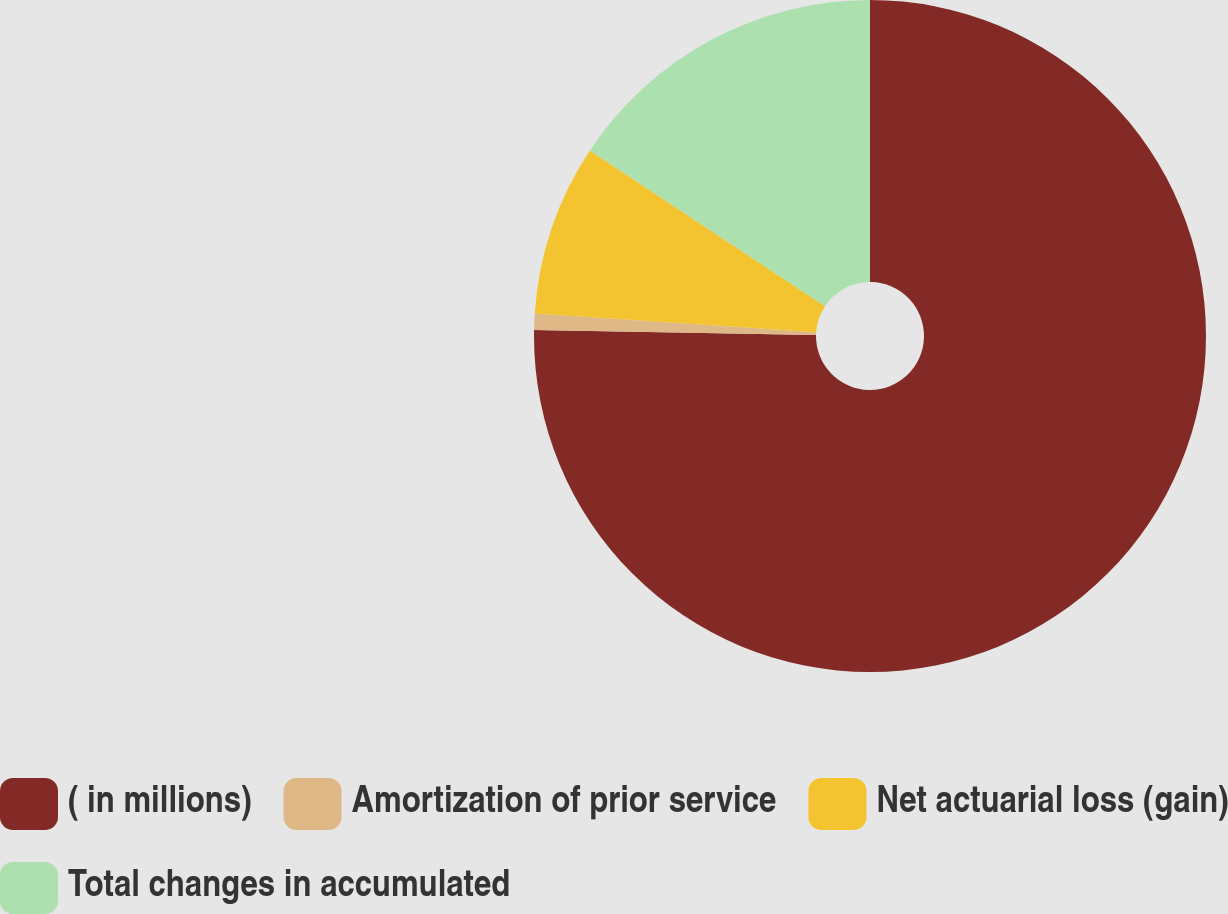<chart> <loc_0><loc_0><loc_500><loc_500><pie_chart><fcel>( in millions)<fcel>Amortization of prior service<fcel>Net actuarial loss (gain)<fcel>Total changes in accumulated<nl><fcel>75.29%<fcel>0.79%<fcel>8.24%<fcel>15.69%<nl></chart> 